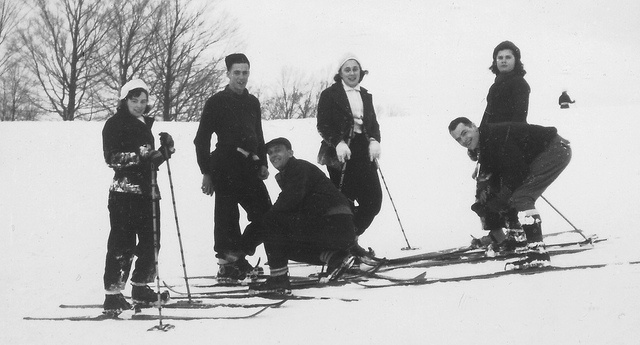Describe the objects in this image and their specific colors. I can see people in silver, black, gray, darkgray, and lightgray tones, people in silver, black, gray, lightgray, and darkgray tones, people in silver, black, gray, lightgray, and darkgray tones, people in silver, black, gray, darkgray, and gainsboro tones, and people in silver, black, gray, lightgray, and darkgray tones in this image. 